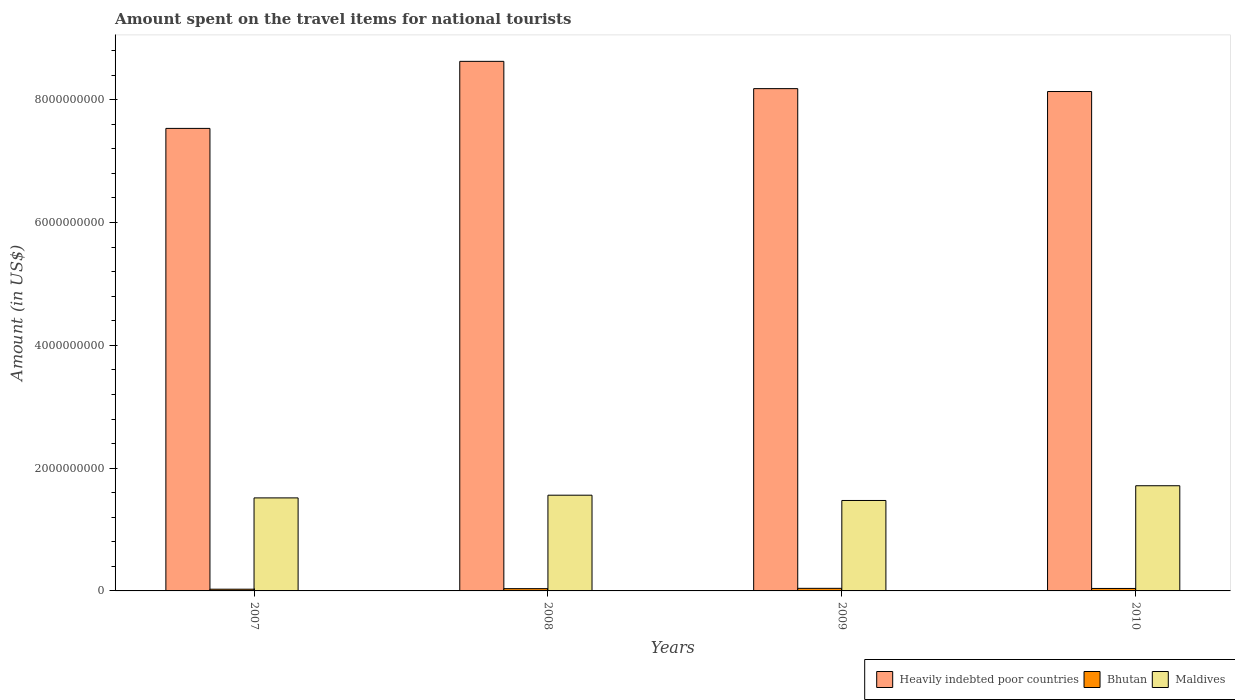How many different coloured bars are there?
Keep it short and to the point. 3. Are the number of bars per tick equal to the number of legend labels?
Your answer should be compact. Yes. Are the number of bars on each tick of the X-axis equal?
Give a very brief answer. Yes. What is the label of the 4th group of bars from the left?
Offer a terse response. 2010. In how many cases, is the number of bars for a given year not equal to the number of legend labels?
Offer a very short reply. 0. What is the amount spent on the travel items for national tourists in Heavily indebted poor countries in 2009?
Your answer should be very brief. 8.18e+09. Across all years, what is the maximum amount spent on the travel items for national tourists in Bhutan?
Make the answer very short. 4.20e+07. Across all years, what is the minimum amount spent on the travel items for national tourists in Bhutan?
Offer a terse response. 2.80e+07. What is the total amount spent on the travel items for national tourists in Heavily indebted poor countries in the graph?
Offer a very short reply. 3.25e+1. What is the difference between the amount spent on the travel items for national tourists in Maldives in 2007 and that in 2008?
Offer a very short reply. -4.40e+07. What is the difference between the amount spent on the travel items for national tourists in Heavily indebted poor countries in 2008 and the amount spent on the travel items for national tourists in Bhutan in 2010?
Offer a very short reply. 8.59e+09. What is the average amount spent on the travel items for national tourists in Maldives per year?
Give a very brief answer. 1.56e+09. In the year 2010, what is the difference between the amount spent on the travel items for national tourists in Heavily indebted poor countries and amount spent on the travel items for national tourists in Maldives?
Provide a succinct answer. 6.42e+09. What is the ratio of the amount spent on the travel items for national tourists in Heavily indebted poor countries in 2009 to that in 2010?
Your answer should be very brief. 1.01. What is the difference between the highest and the lowest amount spent on the travel items for national tourists in Bhutan?
Your response must be concise. 1.40e+07. Is the sum of the amount spent on the travel items for national tourists in Maldives in 2007 and 2010 greater than the maximum amount spent on the travel items for national tourists in Bhutan across all years?
Make the answer very short. Yes. What does the 3rd bar from the left in 2009 represents?
Offer a terse response. Maldives. What does the 1st bar from the right in 2007 represents?
Keep it short and to the point. Maldives. Is it the case that in every year, the sum of the amount spent on the travel items for national tourists in Bhutan and amount spent on the travel items for national tourists in Maldives is greater than the amount spent on the travel items for national tourists in Heavily indebted poor countries?
Ensure brevity in your answer.  No. How many bars are there?
Provide a short and direct response. 12. What is the difference between two consecutive major ticks on the Y-axis?
Offer a very short reply. 2.00e+09. Are the values on the major ticks of Y-axis written in scientific E-notation?
Give a very brief answer. No. Does the graph contain grids?
Offer a terse response. No. Where does the legend appear in the graph?
Your answer should be very brief. Bottom right. How many legend labels are there?
Make the answer very short. 3. How are the legend labels stacked?
Make the answer very short. Horizontal. What is the title of the graph?
Provide a short and direct response. Amount spent on the travel items for national tourists. What is the label or title of the X-axis?
Ensure brevity in your answer.  Years. What is the label or title of the Y-axis?
Make the answer very short. Amount (in US$). What is the Amount (in US$) in Heavily indebted poor countries in 2007?
Make the answer very short. 7.53e+09. What is the Amount (in US$) in Bhutan in 2007?
Offer a terse response. 2.80e+07. What is the Amount (in US$) of Maldives in 2007?
Make the answer very short. 1.52e+09. What is the Amount (in US$) of Heavily indebted poor countries in 2008?
Make the answer very short. 8.63e+09. What is the Amount (in US$) of Bhutan in 2008?
Provide a succinct answer. 3.70e+07. What is the Amount (in US$) of Maldives in 2008?
Give a very brief answer. 1.56e+09. What is the Amount (in US$) in Heavily indebted poor countries in 2009?
Your answer should be very brief. 8.18e+09. What is the Amount (in US$) of Bhutan in 2009?
Keep it short and to the point. 4.20e+07. What is the Amount (in US$) of Maldives in 2009?
Give a very brief answer. 1.47e+09. What is the Amount (in US$) in Heavily indebted poor countries in 2010?
Offer a very short reply. 8.13e+09. What is the Amount (in US$) in Bhutan in 2010?
Your response must be concise. 4.00e+07. What is the Amount (in US$) of Maldives in 2010?
Make the answer very short. 1.71e+09. Across all years, what is the maximum Amount (in US$) in Heavily indebted poor countries?
Keep it short and to the point. 8.63e+09. Across all years, what is the maximum Amount (in US$) of Bhutan?
Provide a succinct answer. 4.20e+07. Across all years, what is the maximum Amount (in US$) of Maldives?
Provide a succinct answer. 1.71e+09. Across all years, what is the minimum Amount (in US$) in Heavily indebted poor countries?
Offer a terse response. 7.53e+09. Across all years, what is the minimum Amount (in US$) of Bhutan?
Offer a terse response. 2.80e+07. Across all years, what is the minimum Amount (in US$) in Maldives?
Offer a very short reply. 1.47e+09. What is the total Amount (in US$) in Heavily indebted poor countries in the graph?
Offer a very short reply. 3.25e+1. What is the total Amount (in US$) of Bhutan in the graph?
Keep it short and to the point. 1.47e+08. What is the total Amount (in US$) of Maldives in the graph?
Offer a terse response. 6.26e+09. What is the difference between the Amount (in US$) in Heavily indebted poor countries in 2007 and that in 2008?
Offer a very short reply. -1.09e+09. What is the difference between the Amount (in US$) of Bhutan in 2007 and that in 2008?
Your response must be concise. -9.00e+06. What is the difference between the Amount (in US$) of Maldives in 2007 and that in 2008?
Offer a very short reply. -4.40e+07. What is the difference between the Amount (in US$) of Heavily indebted poor countries in 2007 and that in 2009?
Make the answer very short. -6.48e+08. What is the difference between the Amount (in US$) of Bhutan in 2007 and that in 2009?
Keep it short and to the point. -1.40e+07. What is the difference between the Amount (in US$) in Maldives in 2007 and that in 2009?
Offer a terse response. 4.20e+07. What is the difference between the Amount (in US$) of Heavily indebted poor countries in 2007 and that in 2010?
Provide a short and direct response. -6.01e+08. What is the difference between the Amount (in US$) in Bhutan in 2007 and that in 2010?
Your answer should be very brief. -1.20e+07. What is the difference between the Amount (in US$) in Maldives in 2007 and that in 2010?
Ensure brevity in your answer.  -1.98e+08. What is the difference between the Amount (in US$) in Heavily indebted poor countries in 2008 and that in 2009?
Keep it short and to the point. 4.44e+08. What is the difference between the Amount (in US$) in Bhutan in 2008 and that in 2009?
Make the answer very short. -5.00e+06. What is the difference between the Amount (in US$) in Maldives in 2008 and that in 2009?
Keep it short and to the point. 8.60e+07. What is the difference between the Amount (in US$) of Heavily indebted poor countries in 2008 and that in 2010?
Ensure brevity in your answer.  4.91e+08. What is the difference between the Amount (in US$) in Maldives in 2008 and that in 2010?
Offer a very short reply. -1.54e+08. What is the difference between the Amount (in US$) in Heavily indebted poor countries in 2009 and that in 2010?
Make the answer very short. 4.70e+07. What is the difference between the Amount (in US$) of Bhutan in 2009 and that in 2010?
Keep it short and to the point. 2.00e+06. What is the difference between the Amount (in US$) of Maldives in 2009 and that in 2010?
Ensure brevity in your answer.  -2.40e+08. What is the difference between the Amount (in US$) of Heavily indebted poor countries in 2007 and the Amount (in US$) of Bhutan in 2008?
Keep it short and to the point. 7.50e+09. What is the difference between the Amount (in US$) of Heavily indebted poor countries in 2007 and the Amount (in US$) of Maldives in 2008?
Provide a short and direct response. 5.97e+09. What is the difference between the Amount (in US$) of Bhutan in 2007 and the Amount (in US$) of Maldives in 2008?
Your answer should be compact. -1.53e+09. What is the difference between the Amount (in US$) in Heavily indebted poor countries in 2007 and the Amount (in US$) in Bhutan in 2009?
Your answer should be compact. 7.49e+09. What is the difference between the Amount (in US$) in Heavily indebted poor countries in 2007 and the Amount (in US$) in Maldives in 2009?
Provide a succinct answer. 6.06e+09. What is the difference between the Amount (in US$) in Bhutan in 2007 and the Amount (in US$) in Maldives in 2009?
Offer a very short reply. -1.44e+09. What is the difference between the Amount (in US$) of Heavily indebted poor countries in 2007 and the Amount (in US$) of Bhutan in 2010?
Provide a short and direct response. 7.49e+09. What is the difference between the Amount (in US$) of Heavily indebted poor countries in 2007 and the Amount (in US$) of Maldives in 2010?
Your answer should be very brief. 5.82e+09. What is the difference between the Amount (in US$) of Bhutan in 2007 and the Amount (in US$) of Maldives in 2010?
Ensure brevity in your answer.  -1.68e+09. What is the difference between the Amount (in US$) in Heavily indebted poor countries in 2008 and the Amount (in US$) in Bhutan in 2009?
Your response must be concise. 8.58e+09. What is the difference between the Amount (in US$) in Heavily indebted poor countries in 2008 and the Amount (in US$) in Maldives in 2009?
Provide a short and direct response. 7.15e+09. What is the difference between the Amount (in US$) in Bhutan in 2008 and the Amount (in US$) in Maldives in 2009?
Keep it short and to the point. -1.44e+09. What is the difference between the Amount (in US$) in Heavily indebted poor countries in 2008 and the Amount (in US$) in Bhutan in 2010?
Offer a terse response. 8.59e+09. What is the difference between the Amount (in US$) in Heavily indebted poor countries in 2008 and the Amount (in US$) in Maldives in 2010?
Your answer should be compact. 6.91e+09. What is the difference between the Amount (in US$) in Bhutan in 2008 and the Amount (in US$) in Maldives in 2010?
Offer a very short reply. -1.68e+09. What is the difference between the Amount (in US$) in Heavily indebted poor countries in 2009 and the Amount (in US$) in Bhutan in 2010?
Your response must be concise. 8.14e+09. What is the difference between the Amount (in US$) of Heavily indebted poor countries in 2009 and the Amount (in US$) of Maldives in 2010?
Ensure brevity in your answer.  6.47e+09. What is the difference between the Amount (in US$) in Bhutan in 2009 and the Amount (in US$) in Maldives in 2010?
Your response must be concise. -1.67e+09. What is the average Amount (in US$) of Heavily indebted poor countries per year?
Your answer should be very brief. 8.12e+09. What is the average Amount (in US$) of Bhutan per year?
Give a very brief answer. 3.68e+07. What is the average Amount (in US$) of Maldives per year?
Offer a very short reply. 1.56e+09. In the year 2007, what is the difference between the Amount (in US$) in Heavily indebted poor countries and Amount (in US$) in Bhutan?
Offer a very short reply. 7.51e+09. In the year 2007, what is the difference between the Amount (in US$) of Heavily indebted poor countries and Amount (in US$) of Maldives?
Offer a terse response. 6.02e+09. In the year 2007, what is the difference between the Amount (in US$) in Bhutan and Amount (in US$) in Maldives?
Ensure brevity in your answer.  -1.49e+09. In the year 2008, what is the difference between the Amount (in US$) in Heavily indebted poor countries and Amount (in US$) in Bhutan?
Provide a short and direct response. 8.59e+09. In the year 2008, what is the difference between the Amount (in US$) in Heavily indebted poor countries and Amount (in US$) in Maldives?
Keep it short and to the point. 7.07e+09. In the year 2008, what is the difference between the Amount (in US$) of Bhutan and Amount (in US$) of Maldives?
Provide a short and direct response. -1.52e+09. In the year 2009, what is the difference between the Amount (in US$) of Heavily indebted poor countries and Amount (in US$) of Bhutan?
Your answer should be very brief. 8.14e+09. In the year 2009, what is the difference between the Amount (in US$) of Heavily indebted poor countries and Amount (in US$) of Maldives?
Your answer should be very brief. 6.71e+09. In the year 2009, what is the difference between the Amount (in US$) of Bhutan and Amount (in US$) of Maldives?
Offer a terse response. -1.43e+09. In the year 2010, what is the difference between the Amount (in US$) of Heavily indebted poor countries and Amount (in US$) of Bhutan?
Provide a succinct answer. 8.09e+09. In the year 2010, what is the difference between the Amount (in US$) of Heavily indebted poor countries and Amount (in US$) of Maldives?
Give a very brief answer. 6.42e+09. In the year 2010, what is the difference between the Amount (in US$) in Bhutan and Amount (in US$) in Maldives?
Offer a terse response. -1.67e+09. What is the ratio of the Amount (in US$) of Heavily indebted poor countries in 2007 to that in 2008?
Provide a short and direct response. 0.87. What is the ratio of the Amount (in US$) of Bhutan in 2007 to that in 2008?
Provide a short and direct response. 0.76. What is the ratio of the Amount (in US$) of Maldives in 2007 to that in 2008?
Make the answer very short. 0.97. What is the ratio of the Amount (in US$) in Heavily indebted poor countries in 2007 to that in 2009?
Offer a very short reply. 0.92. What is the ratio of the Amount (in US$) of Bhutan in 2007 to that in 2009?
Offer a very short reply. 0.67. What is the ratio of the Amount (in US$) of Maldives in 2007 to that in 2009?
Provide a short and direct response. 1.03. What is the ratio of the Amount (in US$) of Heavily indebted poor countries in 2007 to that in 2010?
Make the answer very short. 0.93. What is the ratio of the Amount (in US$) of Maldives in 2007 to that in 2010?
Ensure brevity in your answer.  0.88. What is the ratio of the Amount (in US$) of Heavily indebted poor countries in 2008 to that in 2009?
Provide a succinct answer. 1.05. What is the ratio of the Amount (in US$) in Bhutan in 2008 to that in 2009?
Make the answer very short. 0.88. What is the ratio of the Amount (in US$) of Maldives in 2008 to that in 2009?
Your response must be concise. 1.06. What is the ratio of the Amount (in US$) of Heavily indebted poor countries in 2008 to that in 2010?
Ensure brevity in your answer.  1.06. What is the ratio of the Amount (in US$) of Bhutan in 2008 to that in 2010?
Your answer should be very brief. 0.93. What is the ratio of the Amount (in US$) in Maldives in 2008 to that in 2010?
Offer a very short reply. 0.91. What is the ratio of the Amount (in US$) of Heavily indebted poor countries in 2009 to that in 2010?
Offer a terse response. 1.01. What is the ratio of the Amount (in US$) in Maldives in 2009 to that in 2010?
Offer a terse response. 0.86. What is the difference between the highest and the second highest Amount (in US$) of Heavily indebted poor countries?
Keep it short and to the point. 4.44e+08. What is the difference between the highest and the second highest Amount (in US$) in Maldives?
Your answer should be very brief. 1.54e+08. What is the difference between the highest and the lowest Amount (in US$) of Heavily indebted poor countries?
Your answer should be compact. 1.09e+09. What is the difference between the highest and the lowest Amount (in US$) in Bhutan?
Provide a succinct answer. 1.40e+07. What is the difference between the highest and the lowest Amount (in US$) in Maldives?
Offer a very short reply. 2.40e+08. 